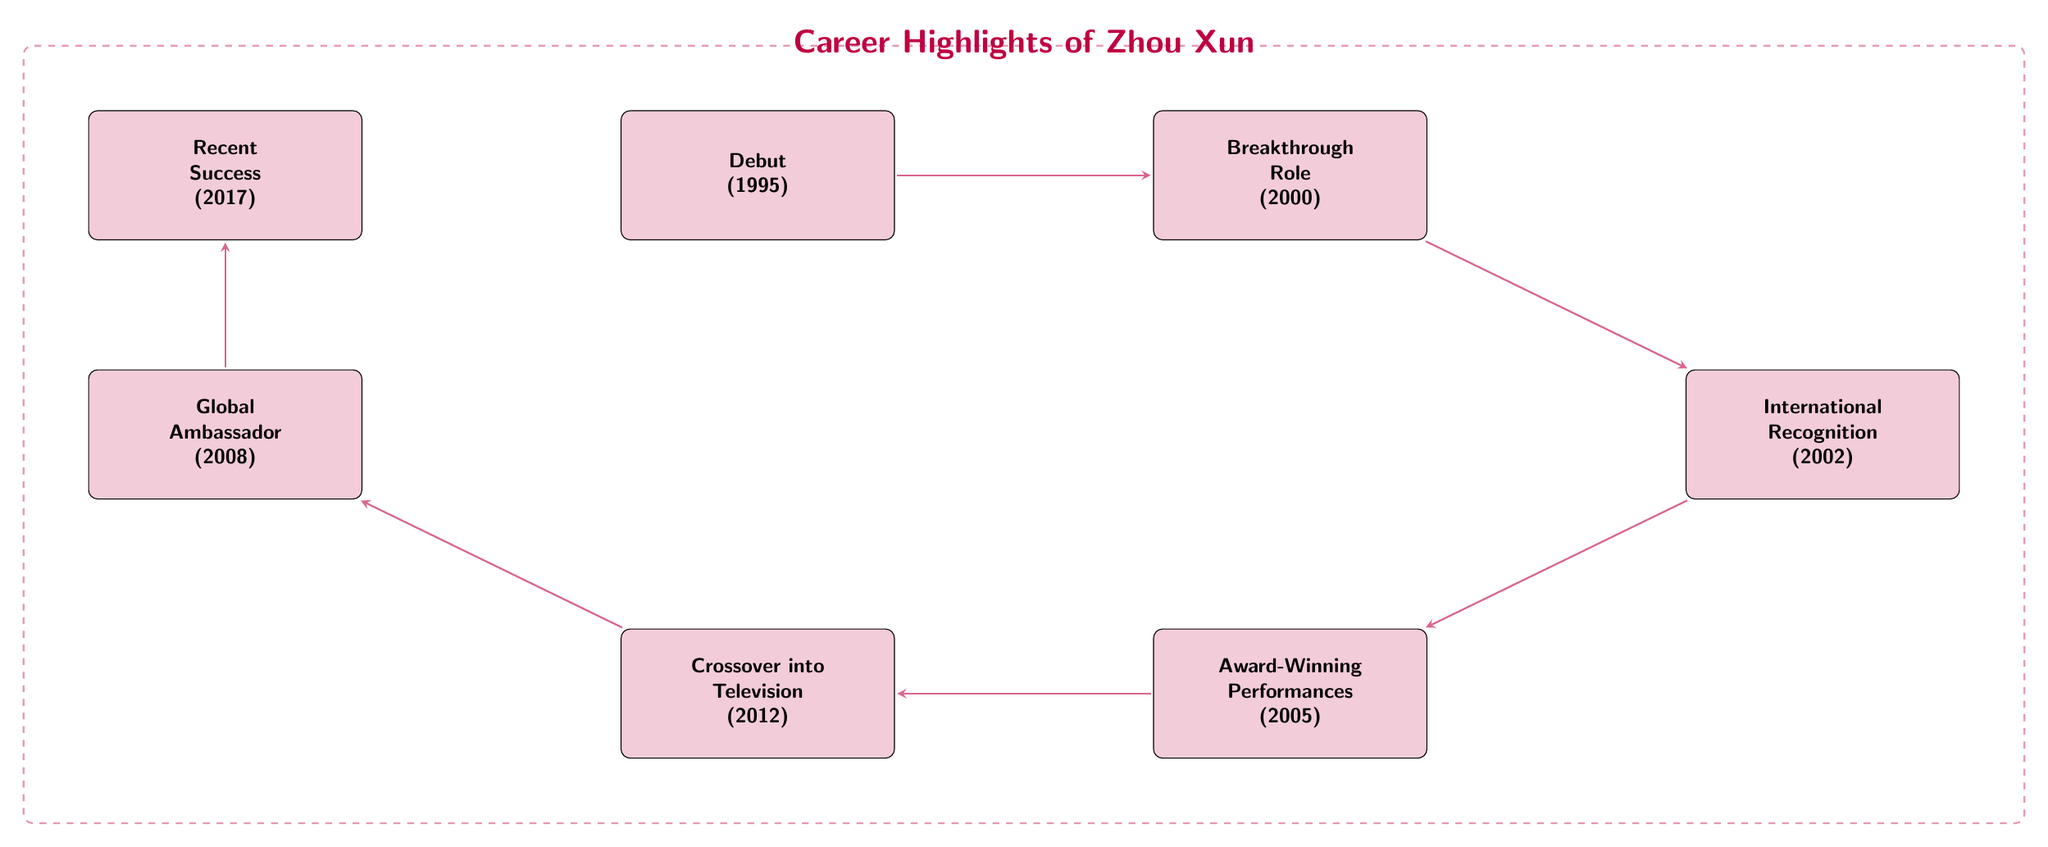What was Zhou Xun's debut film? The diagram indicates that Zhou Xun debuted in the film 'The Pampered Wife' in 1995. This information is shown in the first node labeled 'Debut'.
Answer: The Pampered Wife What year did Zhou Xun receive international recognition? According to the flow chart, the node labeled 'International Recognition' mentions that Zhou Xun won an award in 2002. This node is positioned after the 'Breakthrough Role' node, indicating the timeline of her career.
Answer: 2002 How many significant career milestones are listed in the diagram? The diagram contains a total of seven nodes, each representing a major milestone in Zhou Xun's career. Counting each labeled node confirms this total.
Answer: 7 Which milestone follows Zhou Xun's crossover into television? The flow chart illustrates that 'Crossover into Television' (2012) is followed by the node 'Global Ambassador' (2008). This relationship is shown through the directional arrows connecting the nodes in the diagram.
Answer: Global Ambassador What award did Zhou Xun win for 'Perhaps Love'? The node 'Award-Winning Performances' indicates that Zhou Xun received awards for her role in 'Perhaps Love' (2005), including the Golden Horse Best Actress. This information specifies the type of award but doesn't single out one.
Answer: Golden Horse Best Actress At what stage in her career was Zhou Xun appointed as a Global Ambassador? In the flow of the diagram, 'Global Ambassador' (2008) follows after 'Crossover into Television' (2012). This placement in the timeline indicates that this role came after her work in television series.
Answer: After Crossover into Television Which project is associated with Zhou Xun's recent success? The diagram states that Zhou Xun was acclaimed for her performance in 'Our Time Will Come' (2017), which is listed as the last milestone in the flow chart, showing her recent endeavors in the industry.
Answer: Our Time Will Come 